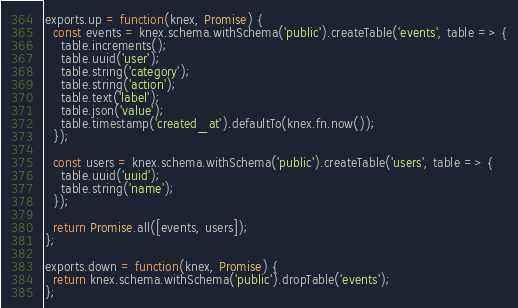<code> <loc_0><loc_0><loc_500><loc_500><_JavaScript_>
exports.up = function(knex, Promise) {
  const events = knex.schema.withSchema('public').createTable('events', table => {
    table.increments();
    table.uuid('user');
    table.string('category');
    table.string('action');
    table.text('label');
    table.json('value');
    table.timestamp('created_at').defaultTo(knex.fn.now());
  });

  const users = knex.schema.withSchema('public').createTable('users', table => {
    table.uuid('uuid');
    table.string('name');
  });

  return Promise.all([events, users]);
};

exports.down = function(knex, Promise) {
  return knex.schema.withSchema('public').dropTable('events');
};
</code> 